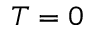Convert formula to latex. <formula><loc_0><loc_0><loc_500><loc_500>T = 0</formula> 